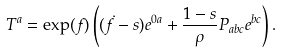<formula> <loc_0><loc_0><loc_500><loc_500>T ^ { a } = \exp ( f ) \left ( ( \dot { f } - s ) e ^ { 0 a } + \frac { 1 - s } { \rho } P _ { a b c } e ^ { b c } \right ) .</formula> 